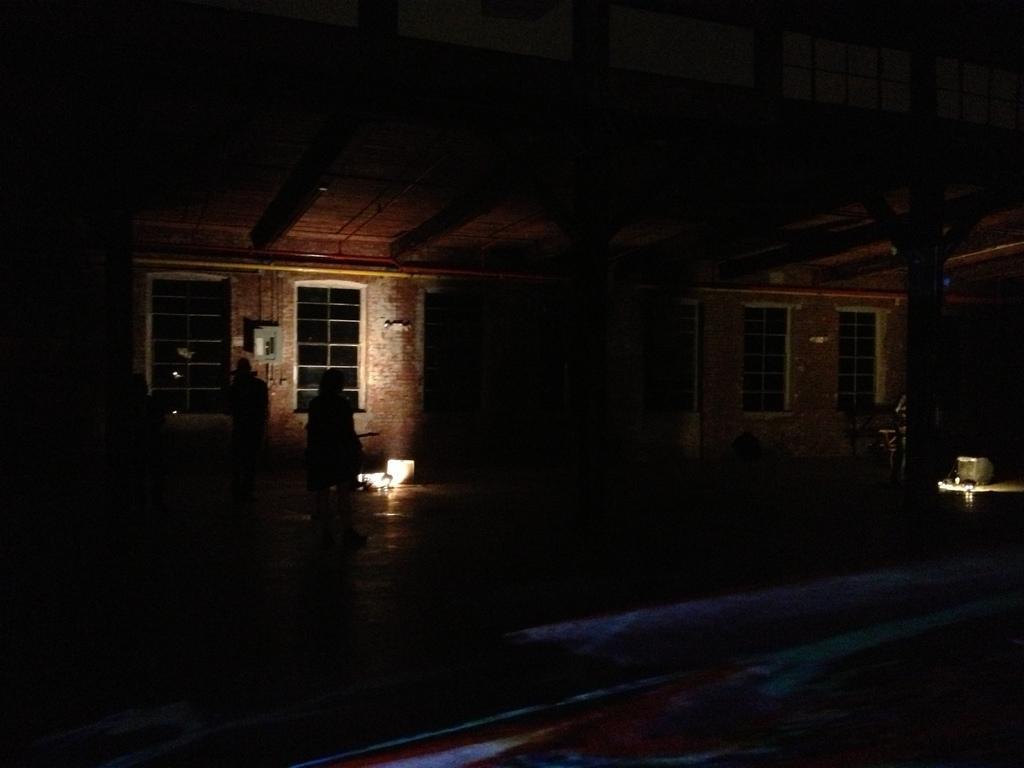In one or two sentences, can you explain what this image depicts? In this picture we can see the house in dark, some people are standing in front of the house. 